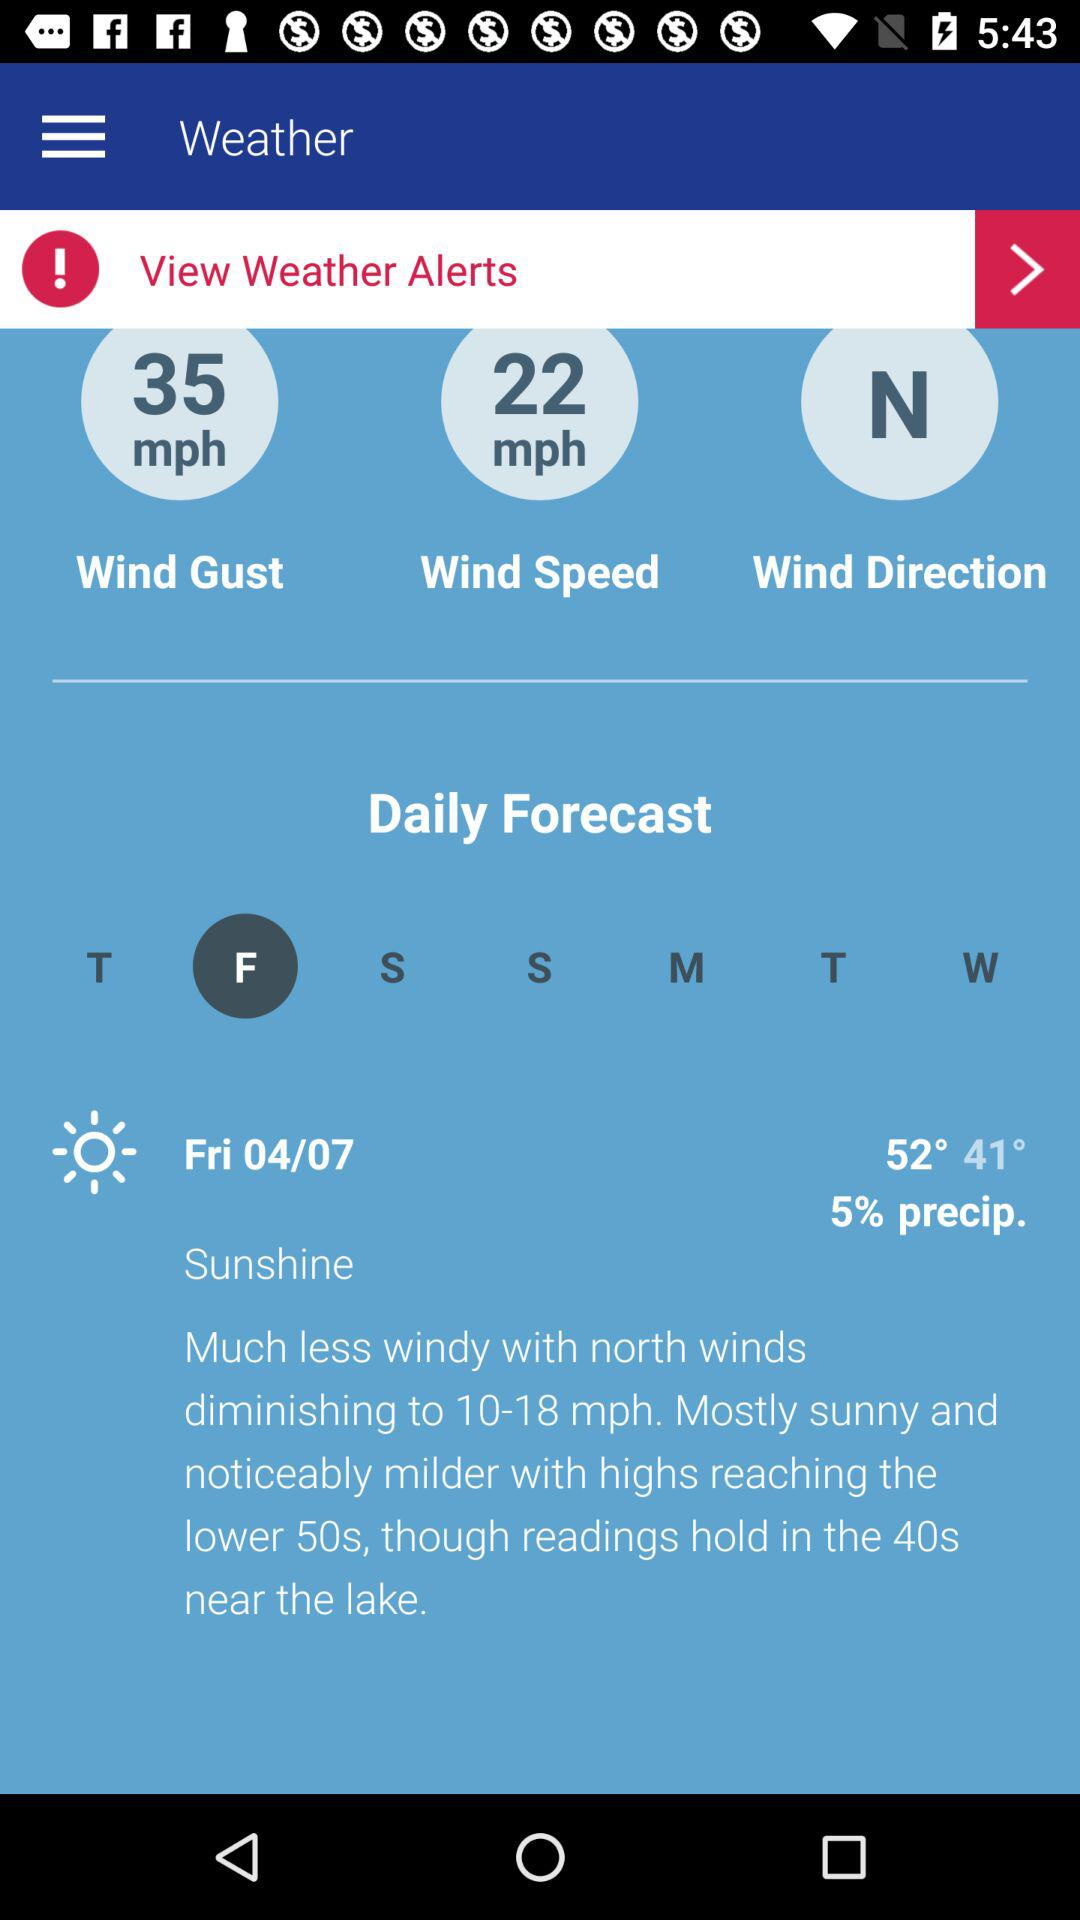What is the direction of the wind? The wind is blowing from the north. 